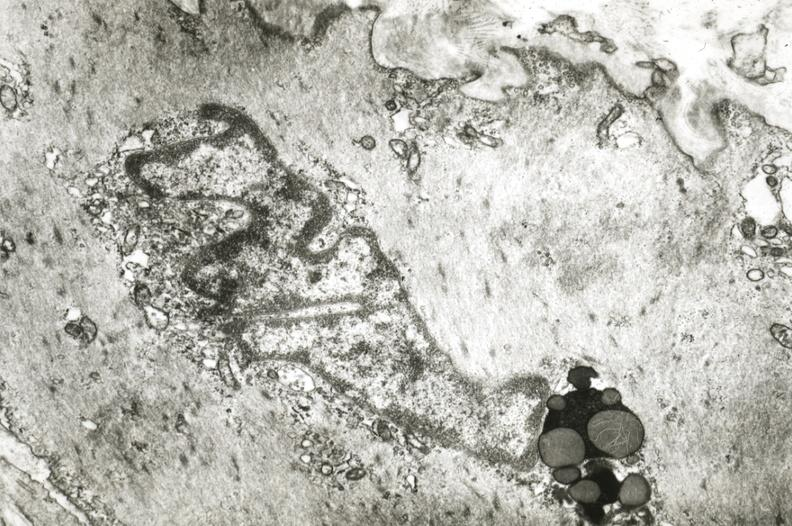s chest and abdomen slide present?
Answer the question using a single word or phrase. No 